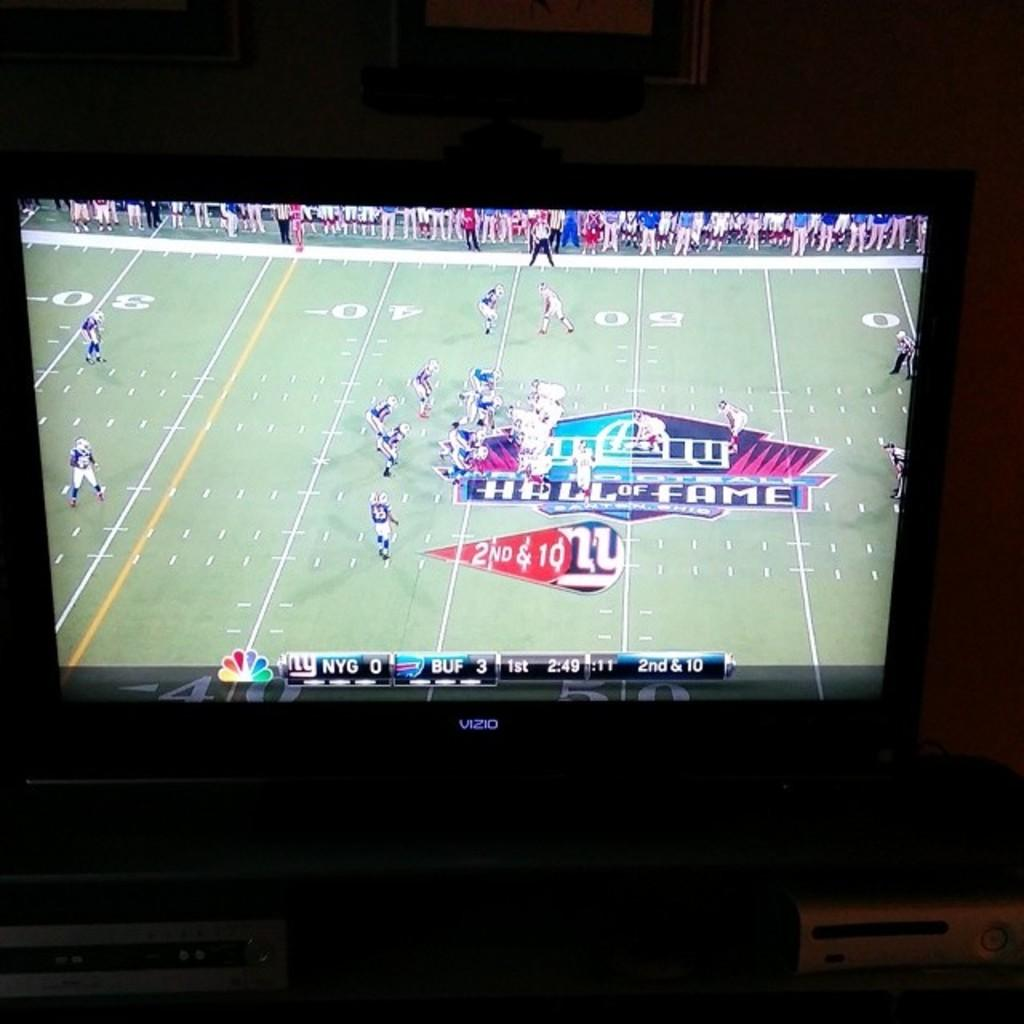<image>
Render a clear and concise summary of the photo. Football showing on television between the New York Giants and Buffalo Bills. 